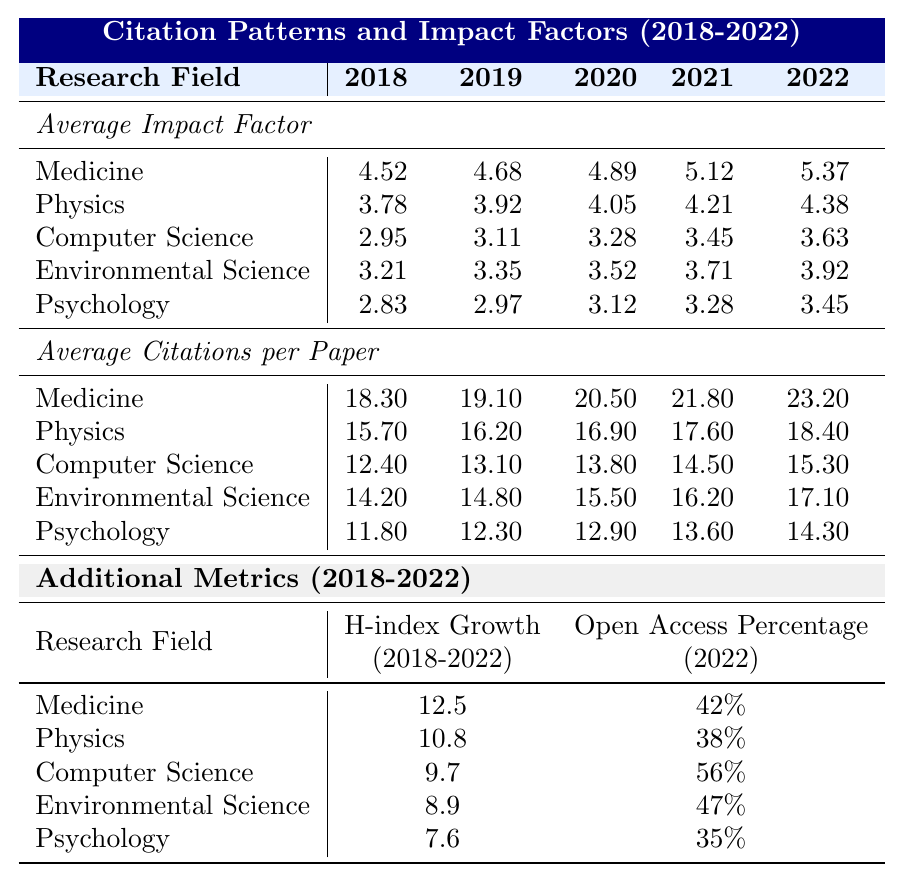What was the average impact factor for Computer Science in 2021? According to the table, the average impact factor for Computer Science in 2021 is listed directly under the relevant column, which shows a value of 3.45.
Answer: 3.45 Which research field had the highest average citations per paper in 2022? In the 2022 row for average citations per paper, Medicine has the highest value at 23.20, compared to the other research fields.
Answer: Medicine What is the average impact factor for Environmental Science over the five years? To find the average, we sum the impact factors from 2018 to 2022: (3.21 + 3.35 + 3.52 + 3.71 + 3.92) = 17.71. Then, we divide by 5, giving us 17.71 / 5 = 3.542.
Answer: 3.54 How much did the average citations per paper for Physics increase from 2018 to 2022? The average citations per paper for Physics in 2018 was 15.70, and in 2022 it was 18.40. We calculate the increase by subtracting the 2018 value from the 2022 value: 18.40 - 15.70 = 2.70.
Answer: 2.70 Which research field had the lowest open access percentage in 2022? Referring to the open access percentage data for 2022, Psychology has the lowest percentage at 35%.
Answer: Psychology Is the H-index growth for Computer Science greater than for Psychology over the period of 2018 to 2022? The H-index growth for Computer Science is 9.7, while for Psychology it is 7.6. Since 9.7 is greater than 7.6, the answer is yes.
Answer: Yes What was the average impact factor of Medicine in 2019 compared to 2021? Medicine's average impact factor in 2019 was 4.68, while in 2021 it was 5.12. The comparison shows that the impact factor increased from 4.68 to 5.12.
Answer: Increased Which research field showed the greatest average increase in H-index from 2018 to 2022? The H-index growth for the five research fields are: Medicine (12.5), Physics (10.8), Computer Science (9.7), Environmental Science (8.9), and Psychology (7.6). Medicine has the highest growth, making it the field with the greatest increase.
Answer: Medicine What is the difference in open access percentage between Computer Science and Environmental Science in 2022? The open access percentage for Computer Science is 56% and for Environmental Science is 47%. To find the difference, we subtract: 56% - 47% = 9%.
Answer: 9% What was the trend in average impact factor for Physics from 2018 to 2022? The table shows the average impact factor for Physics increased each year from 3.78 in 2018 to 4.38 in 2022, indicating a consistent upward trend.
Answer: Upward trend 